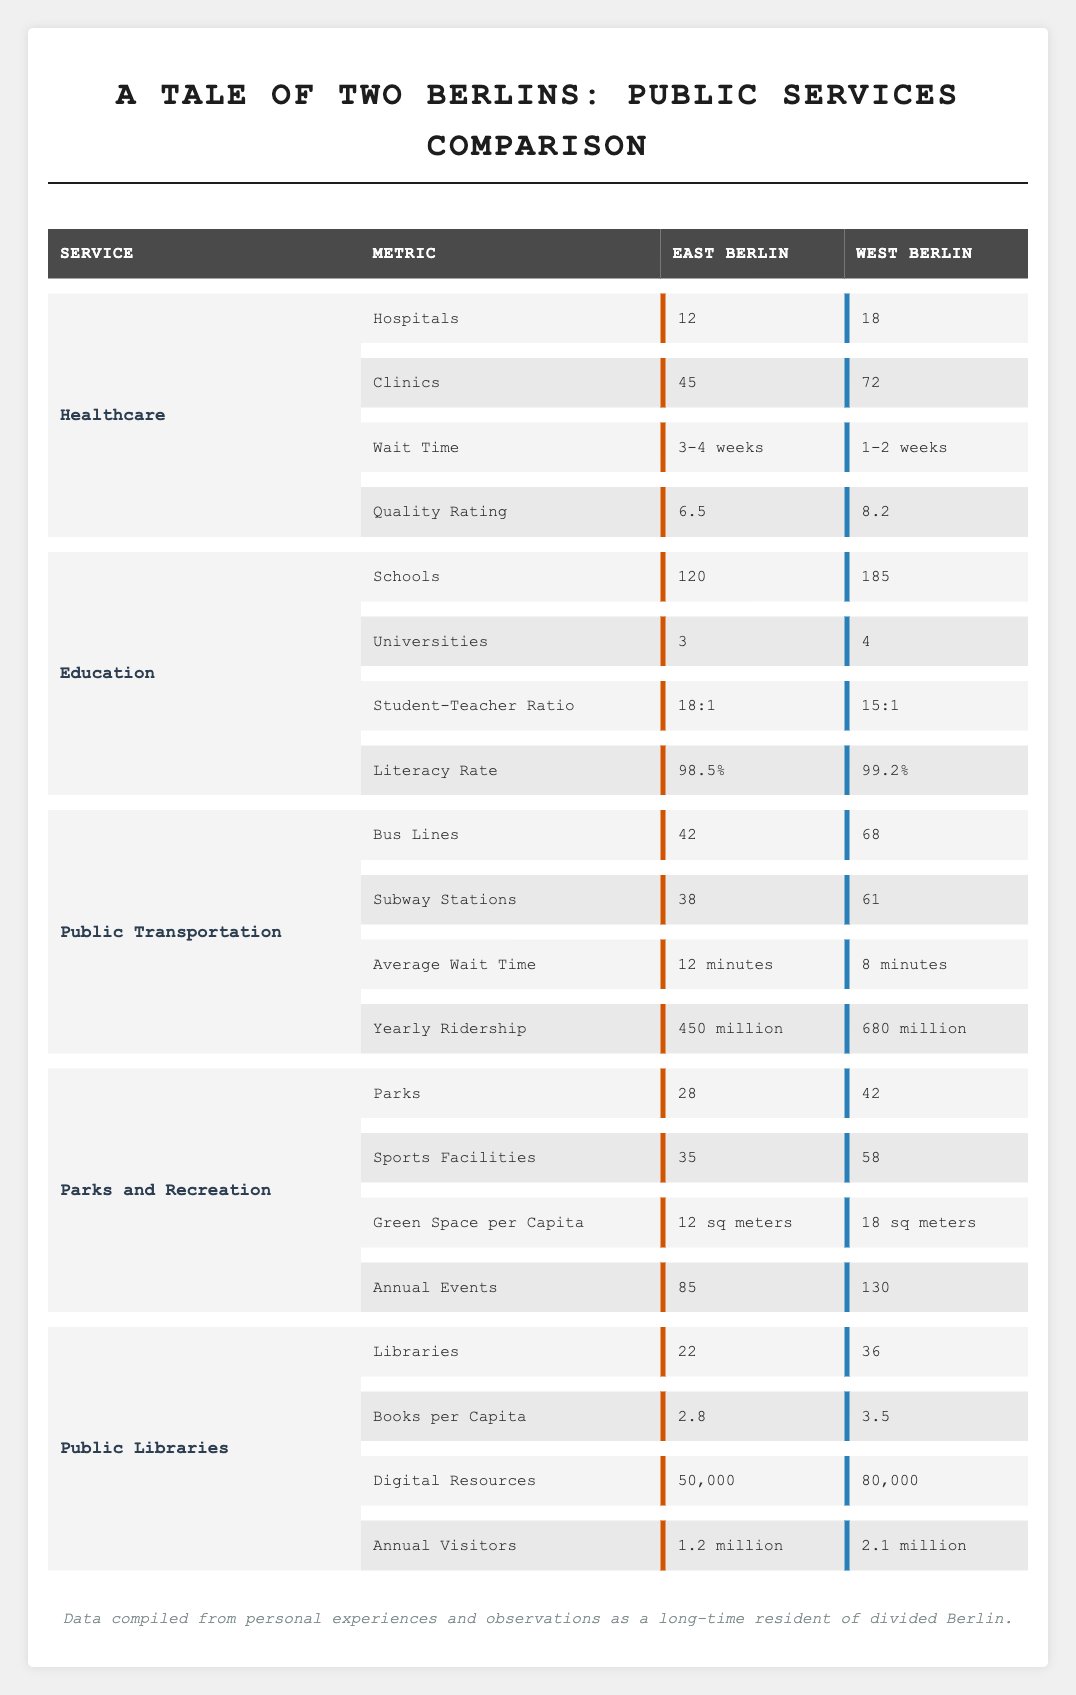What is the wait time for Healthcare services in East Berlin? The table states that the wait time for Healthcare services in East Berlin is "3-4 weeks."
Answer: 3-4 weeks Which sector has more parks, East Berlin or West Berlin? According to the table, West Berlin has 42 parks while East Berlin has 28 parks, so West Berlin has more parks.
Answer: West Berlin What is the total number of sports facilities in both East and West Berlin? East Berlin has 35 sports facilities and West Berlin has 58, summing them gives 35 + 58 = 93.
Answer: 93 Is the literacy rate in East Berlin higher than 98%? The table lists East Berlin's literacy rate as 98.5%, which is indeed higher than 98%.
Answer: Yes What is the difference in the average wait time for public transportation between East Berlin and West Berlin? East Berlin has an average wait time of 12 minutes, while West Berlin has 8 minutes. The difference is 12 - 8 = 4 minutes.
Answer: 4 minutes How many more libraries does West Berlin have compared to East Berlin? West Berlin has 36 libraries and East Berlin has 22. The difference is 36 - 22 = 14.
Answer: 14 What is the ratio of universities in East Berlin to schools in West Berlin? East Berlin has 3 universities and West Berlin has 185 schools. The ratio is 3:185, which simplifies to 1:61.67.
Answer: 1:61.67 Are there more digital resources in West Berlin than in East Berlin? East Berlin has 50,000 digital resources while West Berlin has 80,000, which means West Berlin has more.
Answer: Yes What is the average number of annual visitors to the libraries of both East and West Berlin? East Berlin has 1.2 million annual visitors and West Berlin has 2.1 million. The total visitors are 1.2 + 2.1 = 3.3 million. To find the average, divide by 2: 3.3 million / 2 = 1.65 million.
Answer: 1.65 million What is the combined number of clinics and hospitals in East Berlin? East Berlin has 12 hospitals and 45 clinics. The combined total is 12 + 45 = 57.
Answer: 57 